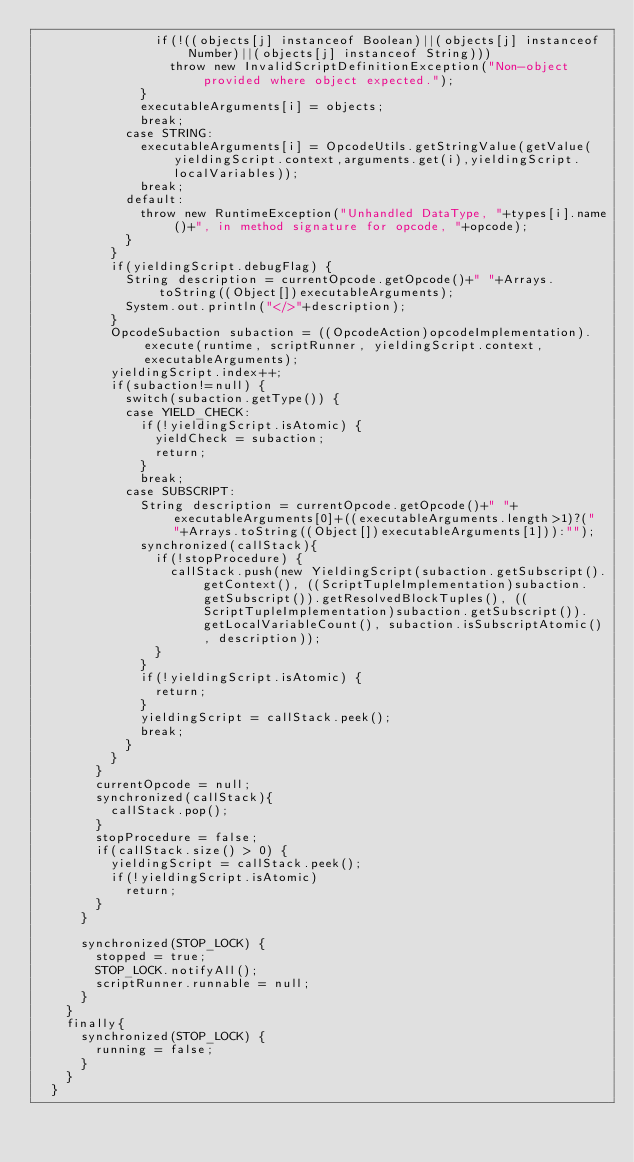<code> <loc_0><loc_0><loc_500><loc_500><_Java_>								if(!((objects[j] instanceof Boolean)||(objects[j] instanceof Number)||(objects[j] instanceof String)))
									throw new InvalidScriptDefinitionException("Non-object provided where object expected.");
							}
							executableArguments[i] = objects;
							break;
						case STRING:
							executableArguments[i] = OpcodeUtils.getStringValue(getValue(yieldingScript.context,arguments.get(i),yieldingScript.localVariables));
							break;
						default:
							throw new RuntimeException("Unhandled DataType, "+types[i].name()+", in method signature for opcode, "+opcode);
						}
					}
					if(yieldingScript.debugFlag) {
						String description = currentOpcode.getOpcode()+" "+Arrays.toString((Object[])executableArguments);
						System.out.println("</>"+description);
					}
					OpcodeSubaction subaction = ((OpcodeAction)opcodeImplementation).execute(runtime, scriptRunner, yieldingScript.context, executableArguments);
					yieldingScript.index++;
					if(subaction!=null) {
						switch(subaction.getType()) {
						case YIELD_CHECK:
							if(!yieldingScript.isAtomic) {
								yieldCheck = subaction;
								return;
							}
							break;
						case SUBSCRIPT:
							String description = currentOpcode.getOpcode()+" "+executableArguments[0]+((executableArguments.length>1)?(" "+Arrays.toString((Object[])executableArguments[1])):"");
							synchronized(callStack){
								if(!stopProcedure) {
									callStack.push(new YieldingScript(subaction.getSubscript().getContext(), ((ScriptTupleImplementation)subaction.getSubscript()).getResolvedBlockTuples(), ((ScriptTupleImplementation)subaction.getSubscript()).getLocalVariableCount(), subaction.isSubscriptAtomic(), description));
								}
							}
							if(!yieldingScript.isAtomic) {
								return;
							}
							yieldingScript = callStack.peek();
							break;
						}
					}
				}
				currentOpcode = null;
				synchronized(callStack){
					callStack.pop();
				}
				stopProcedure = false;
				if(callStack.size() > 0) {
					yieldingScript = callStack.peek();
					if(!yieldingScript.isAtomic)
						return;
				}
			}

			synchronized(STOP_LOCK) {
				stopped = true;
				STOP_LOCK.notifyAll();
				scriptRunner.runnable = null;
			}
		}
		finally{
			synchronized(STOP_LOCK) {
				running = false;
			}
		}
	}
	</code> 